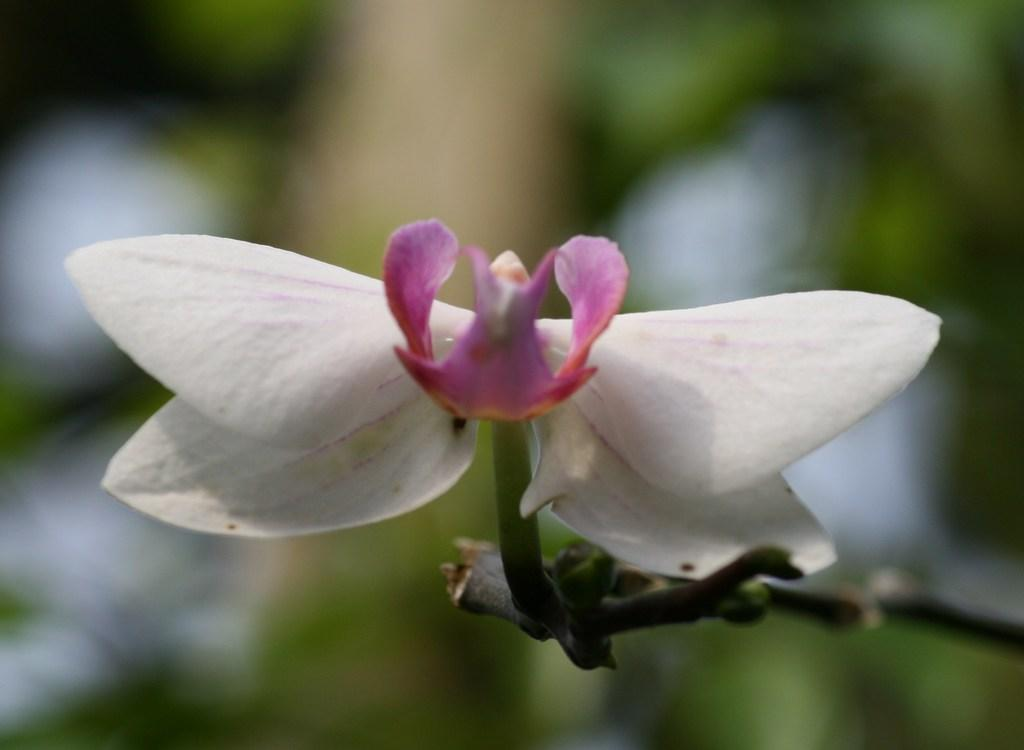What is the main subject of the image? There is a flower in the image. What part of the flower is visible in the image? There is a stem in the image. How would you describe the background of the image? The background of the image is blurred. What type of vegetation can be seen in the background? There is greenery in the background of the image. How many children are holding onto the hook in the image? There are no children or hooks present in the image. 